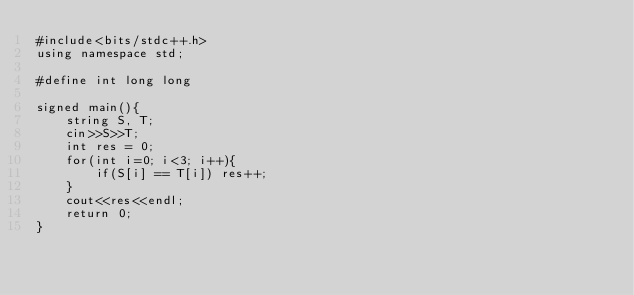<code> <loc_0><loc_0><loc_500><loc_500><_C++_>#include<bits/stdc++.h>
using namespace std;

#define int long long

signed main(){
    string S, T;
    cin>>S>>T;
    int res = 0;
    for(int i=0; i<3; i++){
        if(S[i] == T[i]) res++;
    }
    cout<<res<<endl;
    return 0;
}</code> 